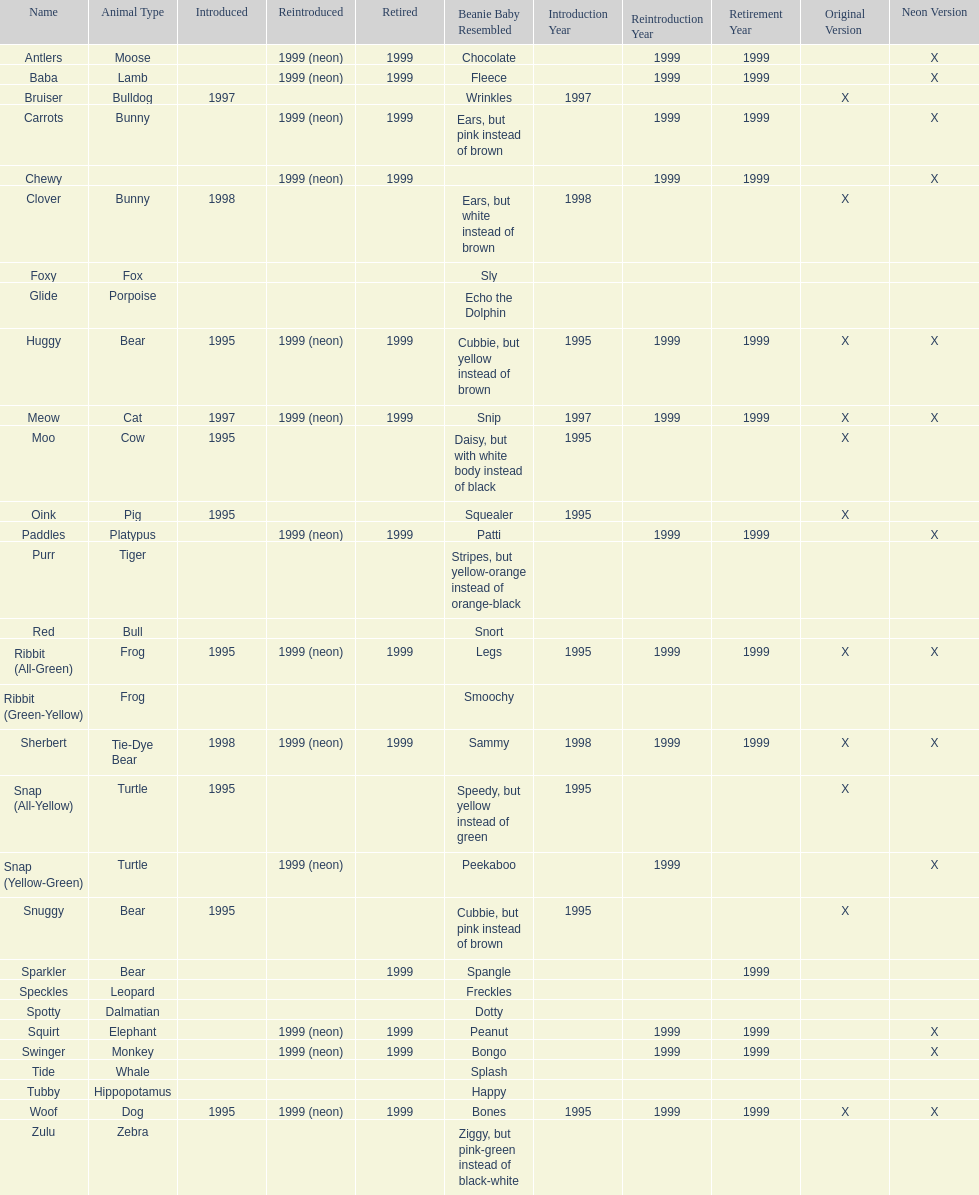Which animal type has the most pillow pals? Bear. 